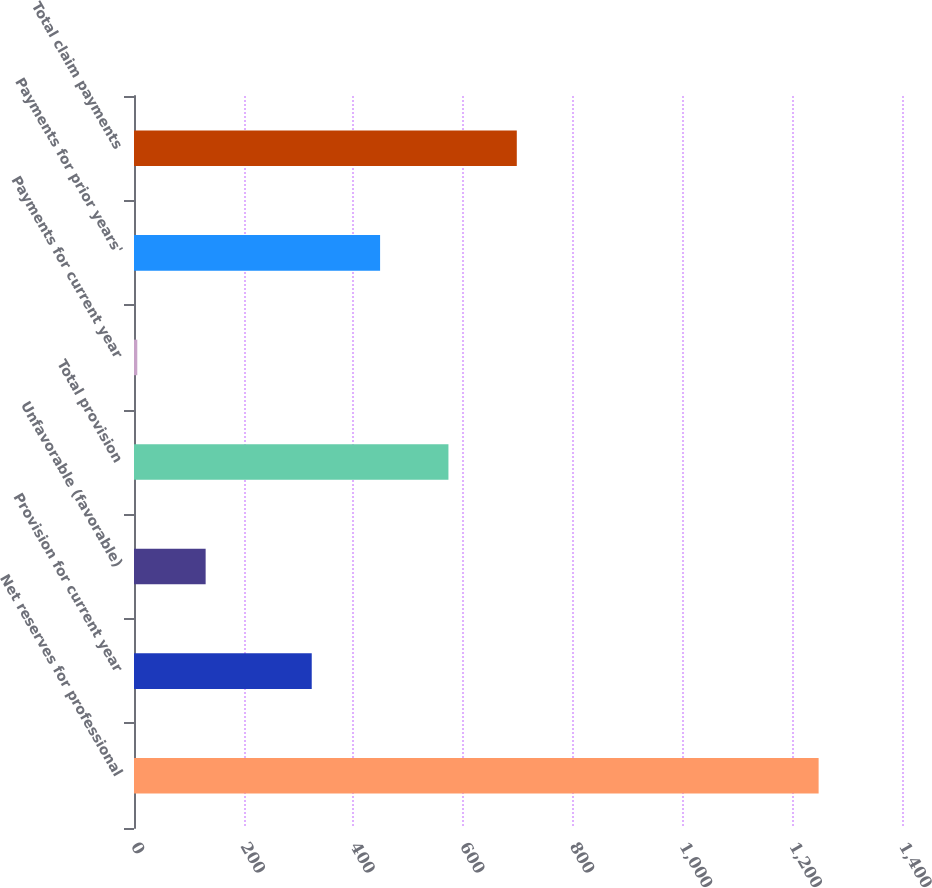Convert chart. <chart><loc_0><loc_0><loc_500><loc_500><bar_chart><fcel>Net reserves for professional<fcel>Provision for current year<fcel>Unfavorable (favorable)<fcel>Total provision<fcel>Payments for current year<fcel>Payments for prior years'<fcel>Total claim payments<nl><fcel>1248<fcel>324<fcel>130.6<fcel>573.2<fcel>6<fcel>448.6<fcel>697.8<nl></chart> 